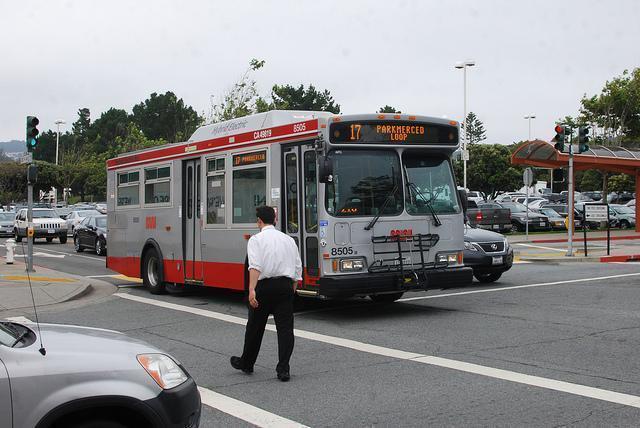After making one full circuit of their route starting from here where will this bus return?
From the following four choices, select the correct answer to address the question.
Options: Next city, mexico, here, depot. Here. 